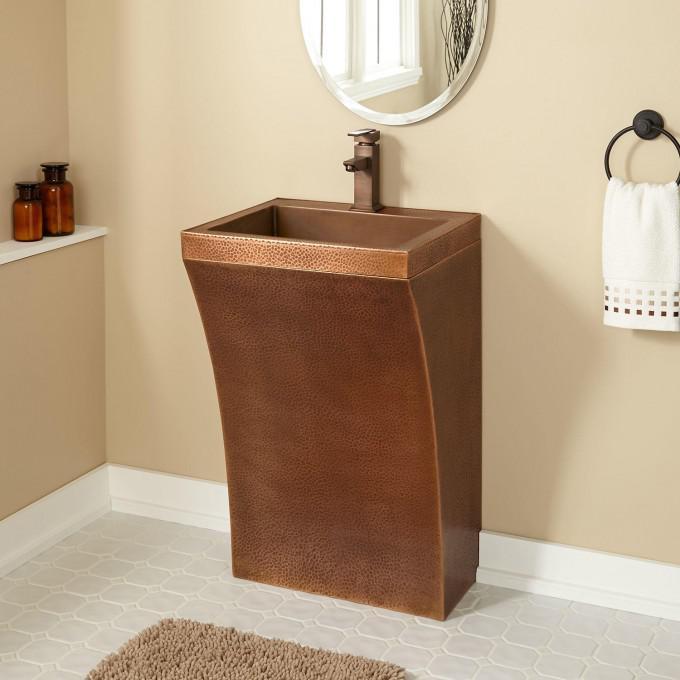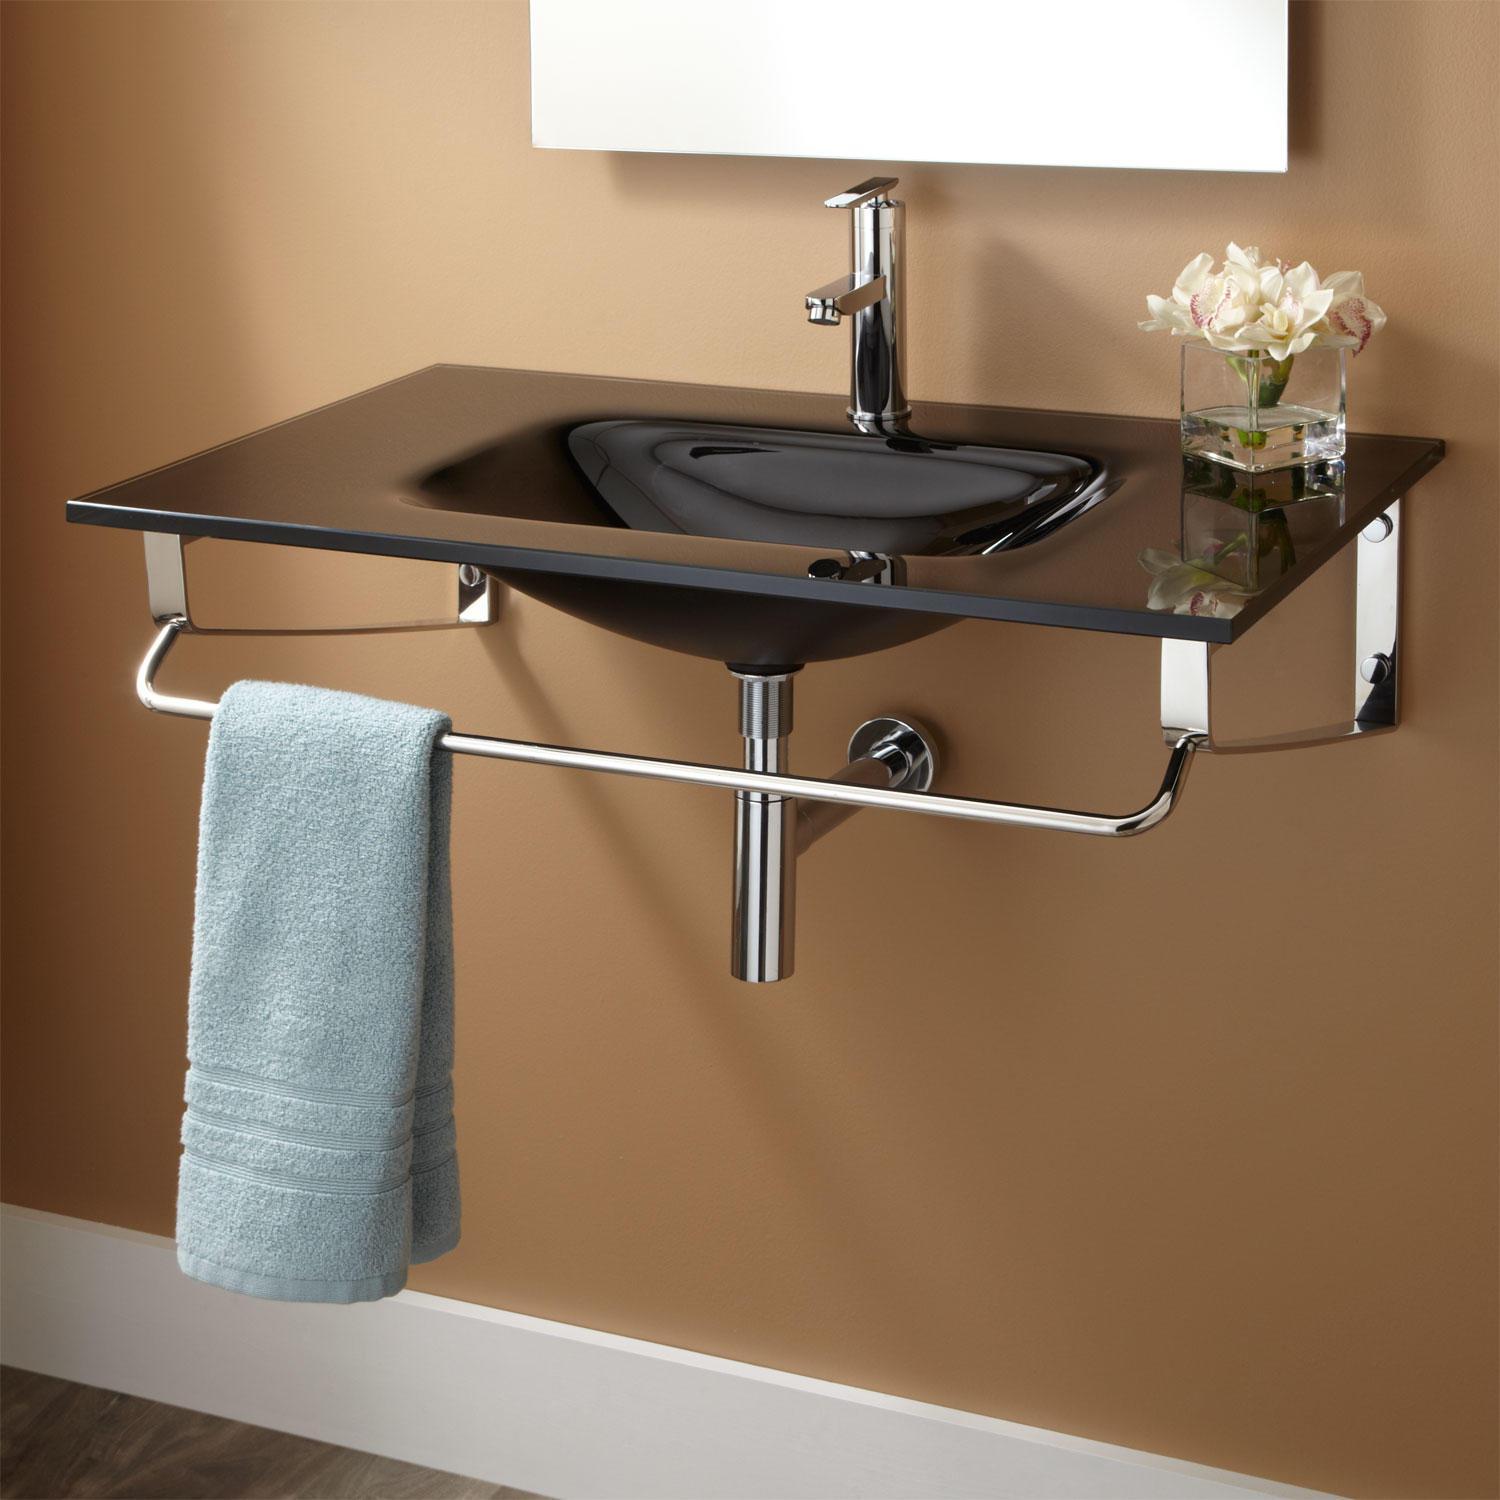The first image is the image on the left, the second image is the image on the right. For the images displayed, is the sentence "A mirror is on a yellow wall above a white sink in one bathroom." factually correct? Answer yes or no. No. The first image is the image on the left, the second image is the image on the right. Examine the images to the left and right. Is the description "One of the images displays more than one sink." accurate? Answer yes or no. No. 